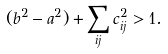Convert formula to latex. <formula><loc_0><loc_0><loc_500><loc_500>( b ^ { 2 } - a ^ { 2 } ) + \sum _ { i j } c _ { i j } ^ { 2 } > 1 .</formula> 